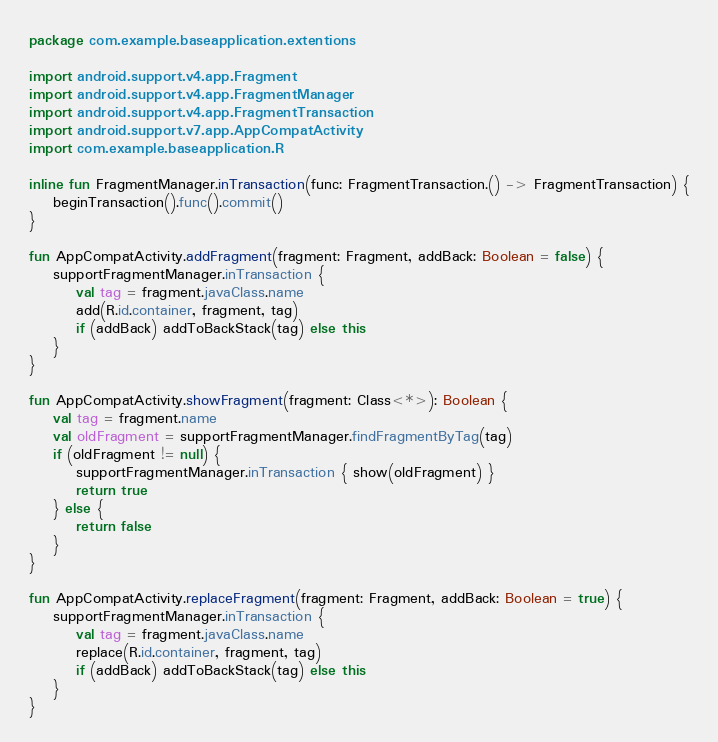<code> <loc_0><loc_0><loc_500><loc_500><_Kotlin_>package com.example.baseapplication.extentions

import android.support.v4.app.Fragment
import android.support.v4.app.FragmentManager
import android.support.v4.app.FragmentTransaction
import android.support.v7.app.AppCompatActivity
import com.example.baseapplication.R

inline fun FragmentManager.inTransaction(func: FragmentTransaction.() -> FragmentTransaction) {
    beginTransaction().func().commit()
}

fun AppCompatActivity.addFragment(fragment: Fragment, addBack: Boolean = false) {
    supportFragmentManager.inTransaction {
        val tag = fragment.javaClass.name
        add(R.id.container, fragment, tag)
        if (addBack) addToBackStack(tag) else this
    }
}

fun AppCompatActivity.showFragment(fragment: Class<*>): Boolean {
    val tag = fragment.name
    val oldFragment = supportFragmentManager.findFragmentByTag(tag)
    if (oldFragment != null) {
        supportFragmentManager.inTransaction { show(oldFragment) }
        return true
    } else {
        return false
    }
}

fun AppCompatActivity.replaceFragment(fragment: Fragment, addBack: Boolean = true) {
    supportFragmentManager.inTransaction {
        val tag = fragment.javaClass.name
        replace(R.id.container, fragment, tag)
        if (addBack) addToBackStack(tag) else this
    }
}</code> 